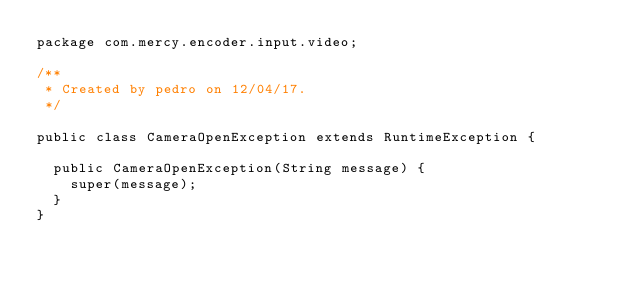<code> <loc_0><loc_0><loc_500><loc_500><_Java_>package com.mercy.encoder.input.video;

/**
 * Created by pedro on 12/04/17.
 */

public class CameraOpenException extends RuntimeException {

  public CameraOpenException(String message) {
    super(message);
  }
}
</code> 